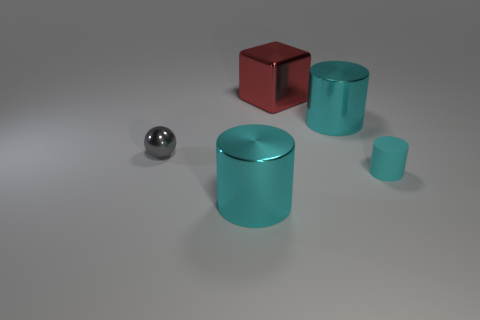What materials appear to be represented by the different objects, judging by their surface textures and reflections? The objects in the image display a variety of materials. The red block has a reflective surface that implies a polished metallic or perhaps a plastic finish. The large and small cylinders appear metallic as well, suggested by their cyan color and lustrous reflections. The small sphere's reflective surface and the distorted reflection it casts suggest that it may represent a chrome or polished steel material. 